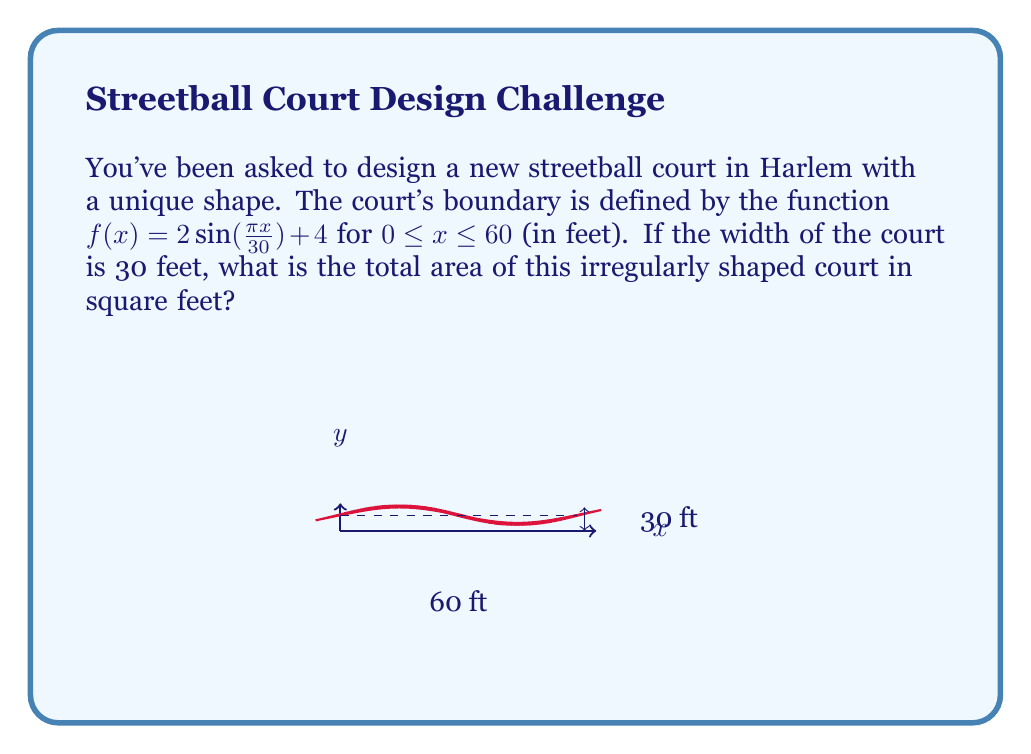Help me with this question. To find the area of this irregularly shaped court, we need to use integration. The area under a curve $f(x)$ from $a$ to $b$ is given by the definite integral:

$$A = \int_a^b f(x) dx$$

In this case, we have:
$f(x) = 2\sin(\frac{\pi x}{30}) + 4$
$a = 0$
$b = 60$

So, our integral becomes:

$$A = \int_0^{60} (2\sin(\frac{\pi x}{30}) + 4) dx$$

To solve this, let's break it into two parts:

1) $\int_0^{60} 2\sin(\frac{\pi x}{30}) dx$
2) $\int_0^{60} 4 dx$

For the first part:
$$\int_0^{60} 2\sin(\frac{\pi x}{30}) dx = -\frac{60}{\pi} \cdot 2\cos(\frac{\pi x}{30})\big|_0^{60}$$
$$= -\frac{120}{\pi} [\cos(2\pi) - \cos(0)] = 0$$

For the second part:
$$\int_0^{60} 4 dx = 4x\big|_0^{60} = 240$$

Adding these together, we get:
$$A = 0 + 240 = 240$$

Therefore, the area of the court is 240 square feet.
Answer: 240 square feet 